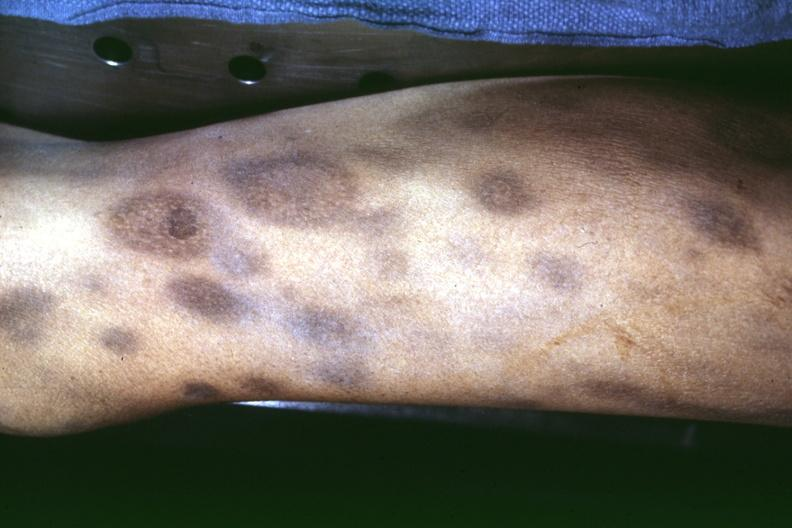does necrotic appearing centers look like pyoderma gangrenosum?
Answer the question using a single word or phrase. Yes 